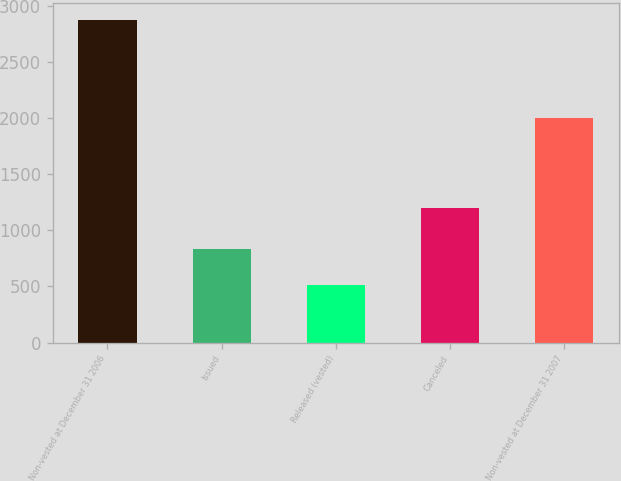Convert chart to OTSL. <chart><loc_0><loc_0><loc_500><loc_500><bar_chart><fcel>Non-vested at December 31 2006<fcel>Issued<fcel>Released (vested)<fcel>Canceled<fcel>Non-vested at December 31 2007<nl><fcel>2878<fcel>830<fcel>514<fcel>1197<fcel>1997<nl></chart> 